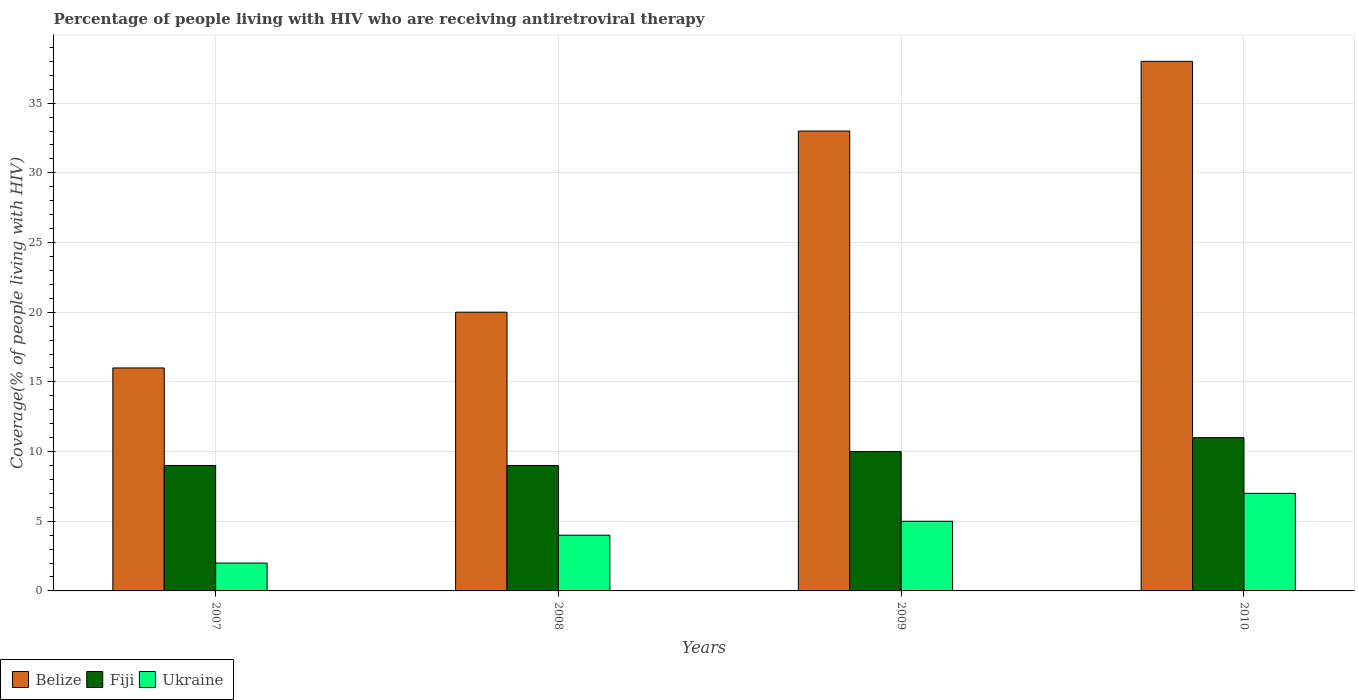How many groups of bars are there?
Keep it short and to the point. 4. Are the number of bars on each tick of the X-axis equal?
Keep it short and to the point. Yes. How many bars are there on the 1st tick from the left?
Give a very brief answer. 3. What is the label of the 3rd group of bars from the left?
Ensure brevity in your answer.  2009. What is the percentage of the HIV infected people who are receiving antiretroviral therapy in Fiji in 2008?
Your response must be concise. 9. Across all years, what is the maximum percentage of the HIV infected people who are receiving antiretroviral therapy in Belize?
Your answer should be very brief. 38. Across all years, what is the minimum percentage of the HIV infected people who are receiving antiretroviral therapy in Belize?
Keep it short and to the point. 16. What is the total percentage of the HIV infected people who are receiving antiretroviral therapy in Fiji in the graph?
Offer a very short reply. 39. What is the difference between the percentage of the HIV infected people who are receiving antiretroviral therapy in Fiji in 2007 and that in 2010?
Your answer should be compact. -2. What is the difference between the percentage of the HIV infected people who are receiving antiretroviral therapy in Ukraine in 2007 and the percentage of the HIV infected people who are receiving antiretroviral therapy in Belize in 2009?
Keep it short and to the point. -31. In the year 2009, what is the difference between the percentage of the HIV infected people who are receiving antiretroviral therapy in Belize and percentage of the HIV infected people who are receiving antiretroviral therapy in Fiji?
Your answer should be compact. 23. What is the ratio of the percentage of the HIV infected people who are receiving antiretroviral therapy in Fiji in 2008 to that in 2010?
Give a very brief answer. 0.82. Is the percentage of the HIV infected people who are receiving antiretroviral therapy in Fiji in 2009 less than that in 2010?
Offer a very short reply. Yes. What is the difference between the highest and the lowest percentage of the HIV infected people who are receiving antiretroviral therapy in Ukraine?
Keep it short and to the point. 5. In how many years, is the percentage of the HIV infected people who are receiving antiretroviral therapy in Belize greater than the average percentage of the HIV infected people who are receiving antiretroviral therapy in Belize taken over all years?
Provide a succinct answer. 2. What does the 2nd bar from the left in 2009 represents?
Offer a terse response. Fiji. What does the 3rd bar from the right in 2007 represents?
Your response must be concise. Belize. Is it the case that in every year, the sum of the percentage of the HIV infected people who are receiving antiretroviral therapy in Fiji and percentage of the HIV infected people who are receiving antiretroviral therapy in Ukraine is greater than the percentage of the HIV infected people who are receiving antiretroviral therapy in Belize?
Ensure brevity in your answer.  No. How many bars are there?
Give a very brief answer. 12. Where does the legend appear in the graph?
Offer a very short reply. Bottom left. What is the title of the graph?
Keep it short and to the point. Percentage of people living with HIV who are receiving antiretroviral therapy. Does "Mongolia" appear as one of the legend labels in the graph?
Offer a very short reply. No. What is the label or title of the X-axis?
Keep it short and to the point. Years. What is the label or title of the Y-axis?
Your answer should be compact. Coverage(% of people living with HIV). What is the Coverage(% of people living with HIV) in Belize in 2007?
Keep it short and to the point. 16. What is the Coverage(% of people living with HIV) of Belize in 2008?
Keep it short and to the point. 20. What is the Coverage(% of people living with HIV) of Fiji in 2008?
Ensure brevity in your answer.  9. What is the Coverage(% of people living with HIV) of Ukraine in 2008?
Offer a very short reply. 4. What is the Coverage(% of people living with HIV) of Fiji in 2009?
Give a very brief answer. 10. What is the Coverage(% of people living with HIV) of Belize in 2010?
Ensure brevity in your answer.  38. What is the Coverage(% of people living with HIV) in Ukraine in 2010?
Your response must be concise. 7. Across all years, what is the minimum Coverage(% of people living with HIV) of Belize?
Offer a terse response. 16. What is the total Coverage(% of people living with HIV) in Belize in the graph?
Your response must be concise. 107. What is the total Coverage(% of people living with HIV) in Fiji in the graph?
Provide a short and direct response. 39. What is the difference between the Coverage(% of people living with HIV) in Belize in 2007 and that in 2008?
Provide a short and direct response. -4. What is the difference between the Coverage(% of people living with HIV) of Ukraine in 2007 and that in 2008?
Offer a very short reply. -2. What is the difference between the Coverage(% of people living with HIV) of Belize in 2007 and that in 2009?
Make the answer very short. -17. What is the difference between the Coverage(% of people living with HIV) of Ukraine in 2007 and that in 2010?
Your answer should be compact. -5. What is the difference between the Coverage(% of people living with HIV) in Belize in 2008 and that in 2009?
Give a very brief answer. -13. What is the difference between the Coverage(% of people living with HIV) in Fiji in 2008 and that in 2009?
Ensure brevity in your answer.  -1. What is the difference between the Coverage(% of people living with HIV) of Ukraine in 2008 and that in 2009?
Provide a succinct answer. -1. What is the difference between the Coverage(% of people living with HIV) of Ukraine in 2008 and that in 2010?
Give a very brief answer. -3. What is the difference between the Coverage(% of people living with HIV) in Belize in 2009 and that in 2010?
Give a very brief answer. -5. What is the difference between the Coverage(% of people living with HIV) in Fiji in 2009 and that in 2010?
Give a very brief answer. -1. What is the difference between the Coverage(% of people living with HIV) in Ukraine in 2009 and that in 2010?
Provide a succinct answer. -2. What is the difference between the Coverage(% of people living with HIV) of Belize in 2007 and the Coverage(% of people living with HIV) of Fiji in 2009?
Ensure brevity in your answer.  6. What is the difference between the Coverage(% of people living with HIV) in Belize in 2007 and the Coverage(% of people living with HIV) in Fiji in 2010?
Your answer should be very brief. 5. What is the difference between the Coverage(% of people living with HIV) of Belize in 2007 and the Coverage(% of people living with HIV) of Ukraine in 2010?
Keep it short and to the point. 9. What is the difference between the Coverage(% of people living with HIV) of Fiji in 2007 and the Coverage(% of people living with HIV) of Ukraine in 2010?
Ensure brevity in your answer.  2. What is the difference between the Coverage(% of people living with HIV) in Belize in 2008 and the Coverage(% of people living with HIV) in Fiji in 2009?
Your answer should be compact. 10. What is the difference between the Coverage(% of people living with HIV) in Belize in 2008 and the Coverage(% of people living with HIV) in Ukraine in 2009?
Offer a very short reply. 15. What is the difference between the Coverage(% of people living with HIV) in Belize in 2008 and the Coverage(% of people living with HIV) in Fiji in 2010?
Provide a succinct answer. 9. What is the difference between the Coverage(% of people living with HIV) in Belize in 2008 and the Coverage(% of people living with HIV) in Ukraine in 2010?
Ensure brevity in your answer.  13. What is the difference between the Coverage(% of people living with HIV) of Belize in 2009 and the Coverage(% of people living with HIV) of Fiji in 2010?
Your response must be concise. 22. What is the difference between the Coverage(% of people living with HIV) in Belize in 2009 and the Coverage(% of people living with HIV) in Ukraine in 2010?
Ensure brevity in your answer.  26. What is the difference between the Coverage(% of people living with HIV) of Fiji in 2009 and the Coverage(% of people living with HIV) of Ukraine in 2010?
Make the answer very short. 3. What is the average Coverage(% of people living with HIV) in Belize per year?
Keep it short and to the point. 26.75. What is the average Coverage(% of people living with HIV) in Fiji per year?
Provide a succinct answer. 9.75. In the year 2007, what is the difference between the Coverage(% of people living with HIV) in Belize and Coverage(% of people living with HIV) in Ukraine?
Offer a terse response. 14. In the year 2007, what is the difference between the Coverage(% of people living with HIV) in Fiji and Coverage(% of people living with HIV) in Ukraine?
Your answer should be compact. 7. In the year 2008, what is the difference between the Coverage(% of people living with HIV) in Belize and Coverage(% of people living with HIV) in Fiji?
Your answer should be compact. 11. In the year 2008, what is the difference between the Coverage(% of people living with HIV) of Belize and Coverage(% of people living with HIV) of Ukraine?
Keep it short and to the point. 16. In the year 2009, what is the difference between the Coverage(% of people living with HIV) of Belize and Coverage(% of people living with HIV) of Fiji?
Your answer should be compact. 23. In the year 2009, what is the difference between the Coverage(% of people living with HIV) in Belize and Coverage(% of people living with HIV) in Ukraine?
Your answer should be very brief. 28. In the year 2009, what is the difference between the Coverage(% of people living with HIV) of Fiji and Coverage(% of people living with HIV) of Ukraine?
Keep it short and to the point. 5. In the year 2010, what is the difference between the Coverage(% of people living with HIV) of Belize and Coverage(% of people living with HIV) of Ukraine?
Keep it short and to the point. 31. In the year 2010, what is the difference between the Coverage(% of people living with HIV) of Fiji and Coverage(% of people living with HIV) of Ukraine?
Keep it short and to the point. 4. What is the ratio of the Coverage(% of people living with HIV) in Ukraine in 2007 to that in 2008?
Offer a terse response. 0.5. What is the ratio of the Coverage(% of people living with HIV) in Belize in 2007 to that in 2009?
Ensure brevity in your answer.  0.48. What is the ratio of the Coverage(% of people living with HIV) in Belize in 2007 to that in 2010?
Offer a terse response. 0.42. What is the ratio of the Coverage(% of people living with HIV) in Fiji in 2007 to that in 2010?
Give a very brief answer. 0.82. What is the ratio of the Coverage(% of people living with HIV) in Ukraine in 2007 to that in 2010?
Your response must be concise. 0.29. What is the ratio of the Coverage(% of people living with HIV) in Belize in 2008 to that in 2009?
Provide a succinct answer. 0.61. What is the ratio of the Coverage(% of people living with HIV) in Fiji in 2008 to that in 2009?
Keep it short and to the point. 0.9. What is the ratio of the Coverage(% of people living with HIV) of Ukraine in 2008 to that in 2009?
Your answer should be very brief. 0.8. What is the ratio of the Coverage(% of people living with HIV) of Belize in 2008 to that in 2010?
Give a very brief answer. 0.53. What is the ratio of the Coverage(% of people living with HIV) of Fiji in 2008 to that in 2010?
Provide a short and direct response. 0.82. What is the ratio of the Coverage(% of people living with HIV) of Belize in 2009 to that in 2010?
Make the answer very short. 0.87. What is the ratio of the Coverage(% of people living with HIV) in Fiji in 2009 to that in 2010?
Give a very brief answer. 0.91. What is the difference between the highest and the second highest Coverage(% of people living with HIV) of Fiji?
Keep it short and to the point. 1. What is the difference between the highest and the lowest Coverage(% of people living with HIV) of Belize?
Provide a short and direct response. 22. What is the difference between the highest and the lowest Coverage(% of people living with HIV) in Ukraine?
Give a very brief answer. 5. 